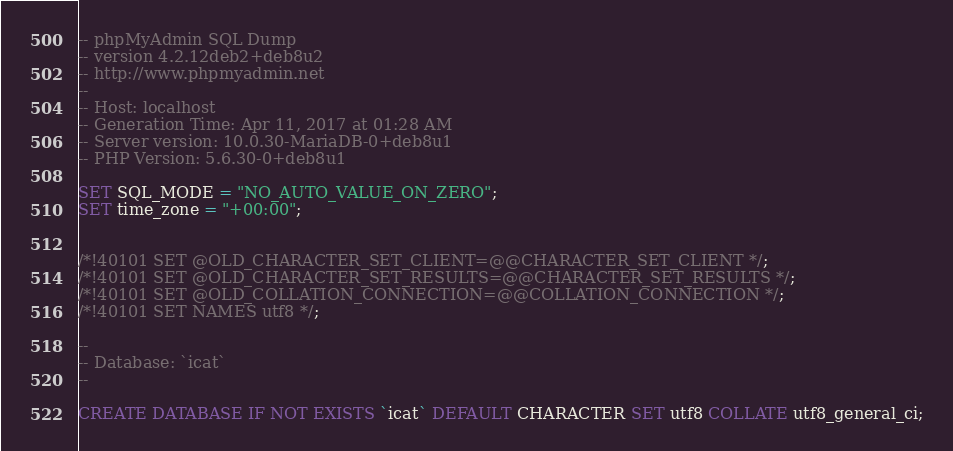<code> <loc_0><loc_0><loc_500><loc_500><_SQL_>-- phpMyAdmin SQL Dump
-- version 4.2.12deb2+deb8u2
-- http://www.phpmyadmin.net
--
-- Host: localhost
-- Generation Time: Apr 11, 2017 at 01:28 AM
-- Server version: 10.0.30-MariaDB-0+deb8u1
-- PHP Version: 5.6.30-0+deb8u1

SET SQL_MODE = "NO_AUTO_VALUE_ON_ZERO";
SET time_zone = "+00:00";


/*!40101 SET @OLD_CHARACTER_SET_CLIENT=@@CHARACTER_SET_CLIENT */;
/*!40101 SET @OLD_CHARACTER_SET_RESULTS=@@CHARACTER_SET_RESULTS */;
/*!40101 SET @OLD_COLLATION_CONNECTION=@@COLLATION_CONNECTION */;
/*!40101 SET NAMES utf8 */;

--
-- Database: `icat`
--

CREATE DATABASE IF NOT EXISTS `icat` DEFAULT CHARACTER SET utf8 COLLATE utf8_general_ci;</code> 